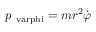Convert formula to latex. <formula><loc_0><loc_0><loc_500><loc_500>p _ { \ v a r p h i } = m r ^ { 2 } { \dot { \varphi } }</formula> 